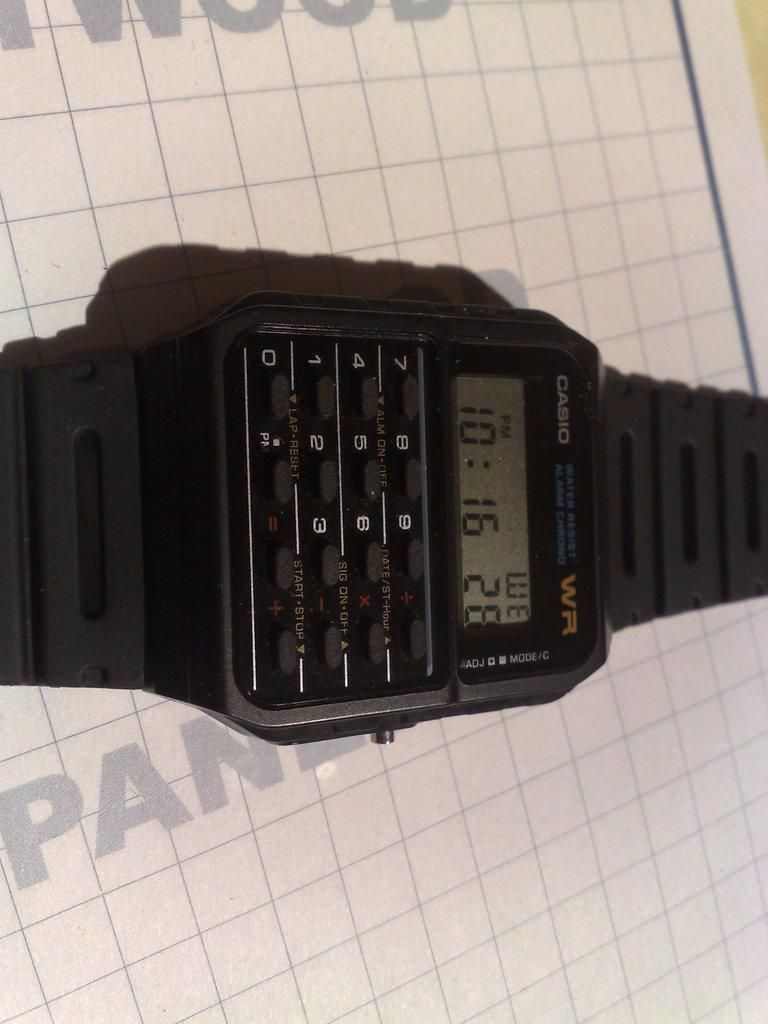What object is the main focus of the picture? There is a watch in the picture. What features does the watch have? The watch has buttons and a screen. On what surface is the watch placed? The watch is placed on a white surface. What type of badge is displayed on the watch's screen? There is no badge displayed on the watch's screen in the image. What organization does the watch represent? The image does not provide any information about the watch representing a specific organization. 